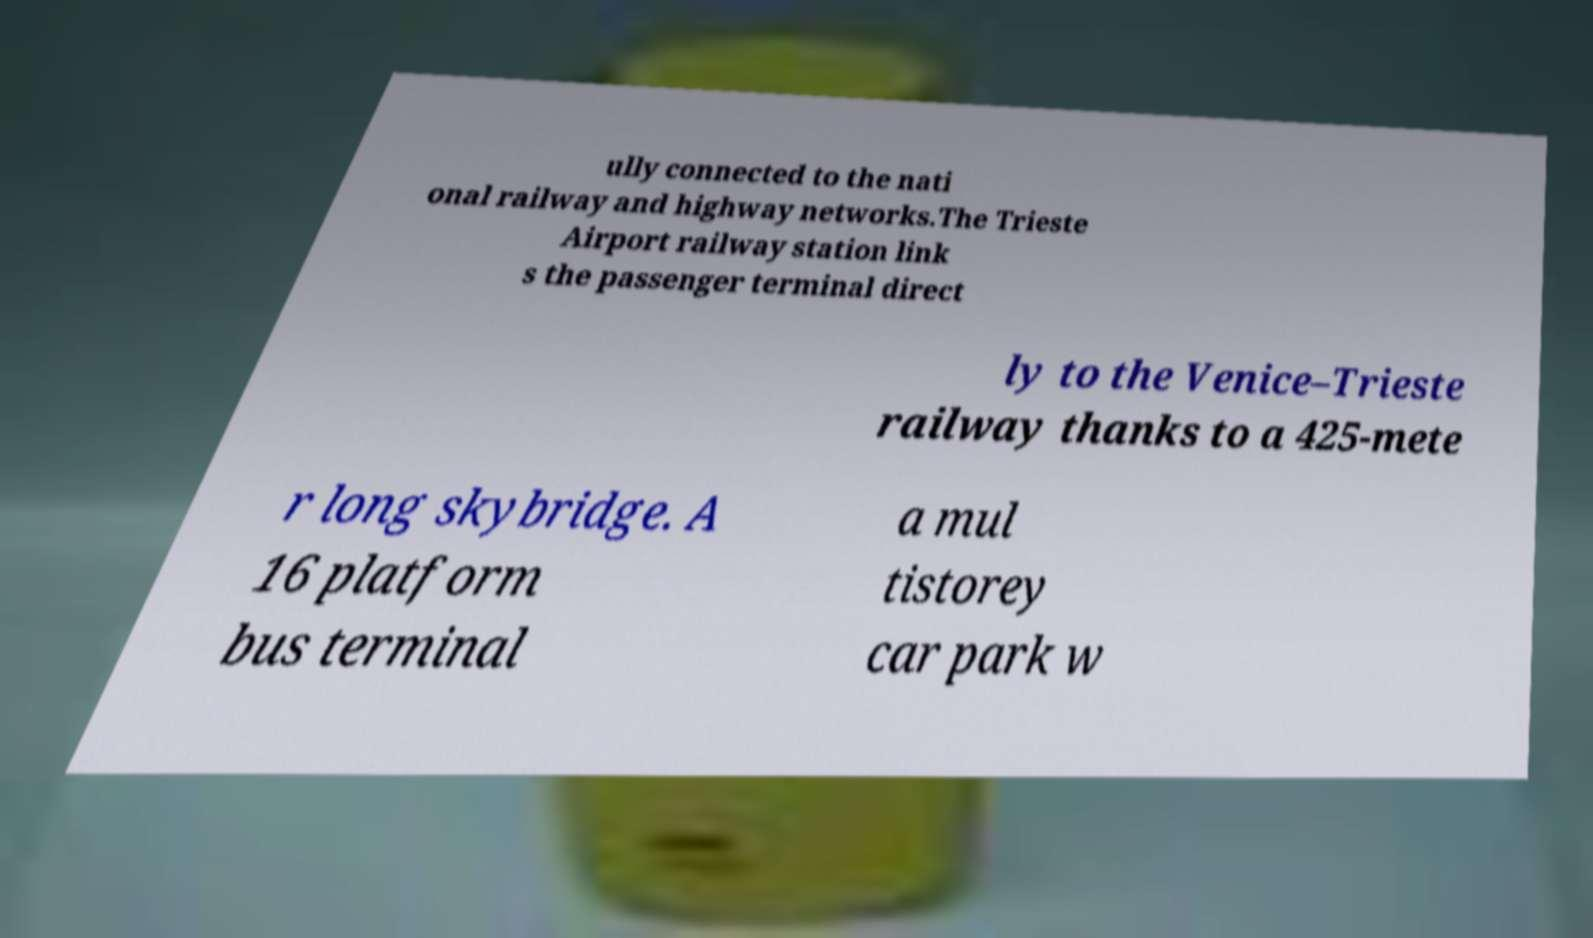There's text embedded in this image that I need extracted. Can you transcribe it verbatim? ully connected to the nati onal railway and highway networks.The Trieste Airport railway station link s the passenger terminal direct ly to the Venice–Trieste railway thanks to a 425-mete r long skybridge. A 16 platform bus terminal a mul tistorey car park w 